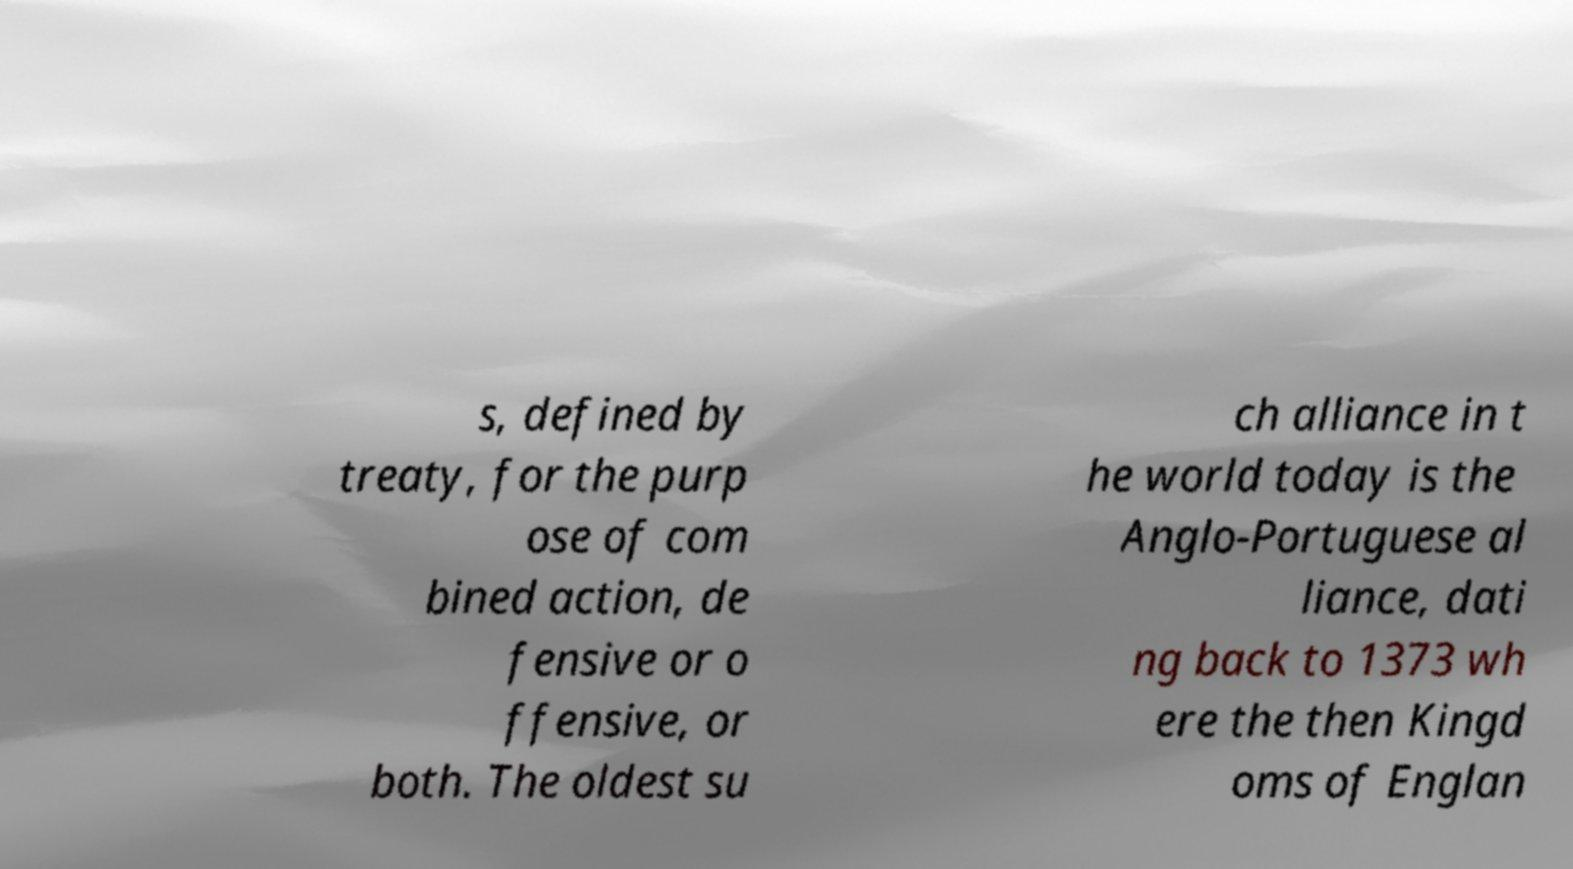Could you assist in decoding the text presented in this image and type it out clearly? s, defined by treaty, for the purp ose of com bined action, de fensive or o ffensive, or both. The oldest su ch alliance in t he world today is the Anglo-Portuguese al liance, dati ng back to 1373 wh ere the then Kingd oms of Englan 